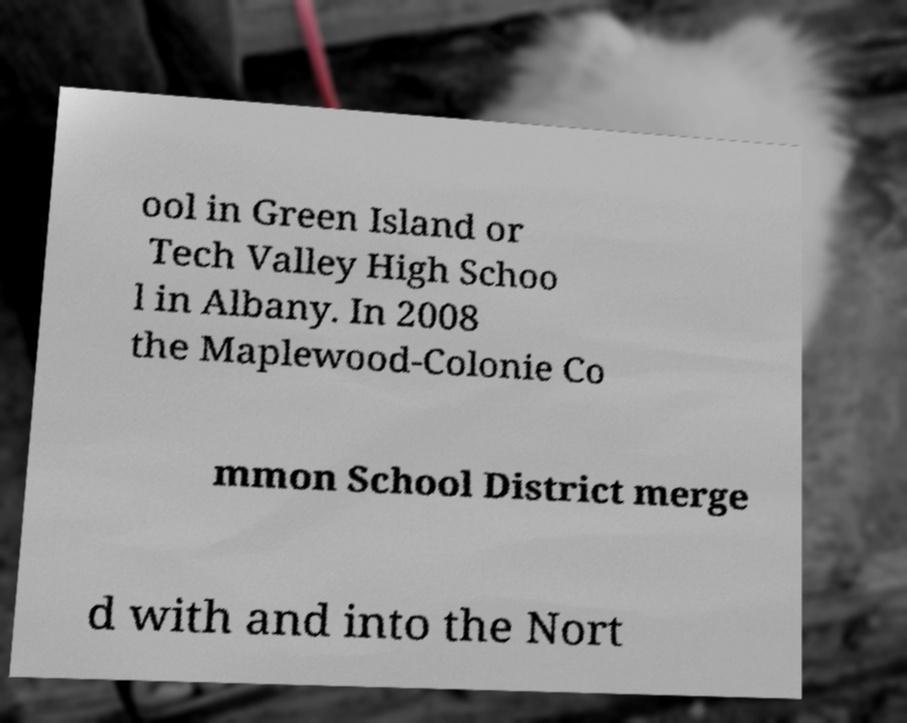Can you read and provide the text displayed in the image?This photo seems to have some interesting text. Can you extract and type it out for me? ool in Green Island or Tech Valley High Schoo l in Albany. In 2008 the Maplewood-Colonie Co mmon School District merge d with and into the Nort 